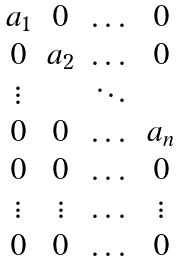<formula> <loc_0><loc_0><loc_500><loc_500>\begin{matrix} a _ { 1 } & 0 & \dots & 0 \\ 0 & a _ { 2 } & \dots & 0 \\ \vdots & & \ddots & \\ 0 & 0 & \dots & a _ { n } \\ 0 & 0 & \dots & 0 \\ \vdots & \vdots & \dots & \vdots \\ 0 & 0 & \dots & 0 \end{matrix}</formula> 